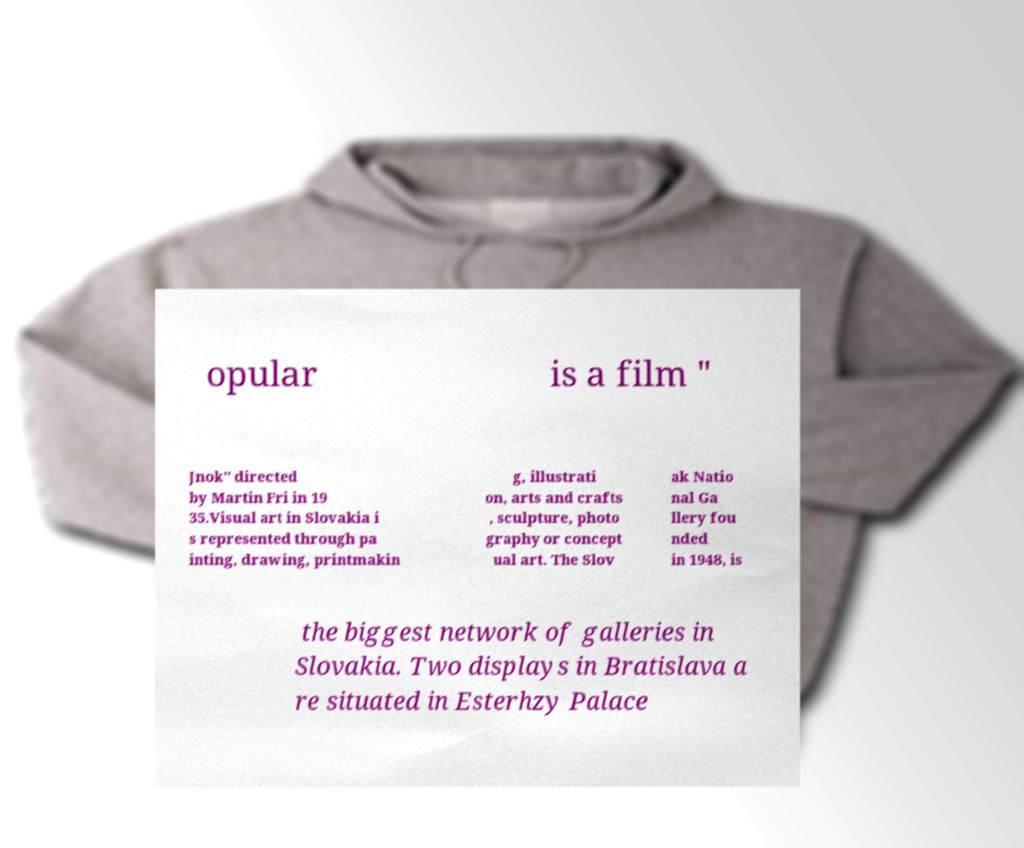Please identify and transcribe the text found in this image. opular is a film " Jnok" directed by Martin Fri in 19 35.Visual art in Slovakia i s represented through pa inting, drawing, printmakin g, illustrati on, arts and crafts , sculpture, photo graphy or concept ual art. The Slov ak Natio nal Ga llery fou nded in 1948, is the biggest network of galleries in Slovakia. Two displays in Bratislava a re situated in Esterhzy Palace 